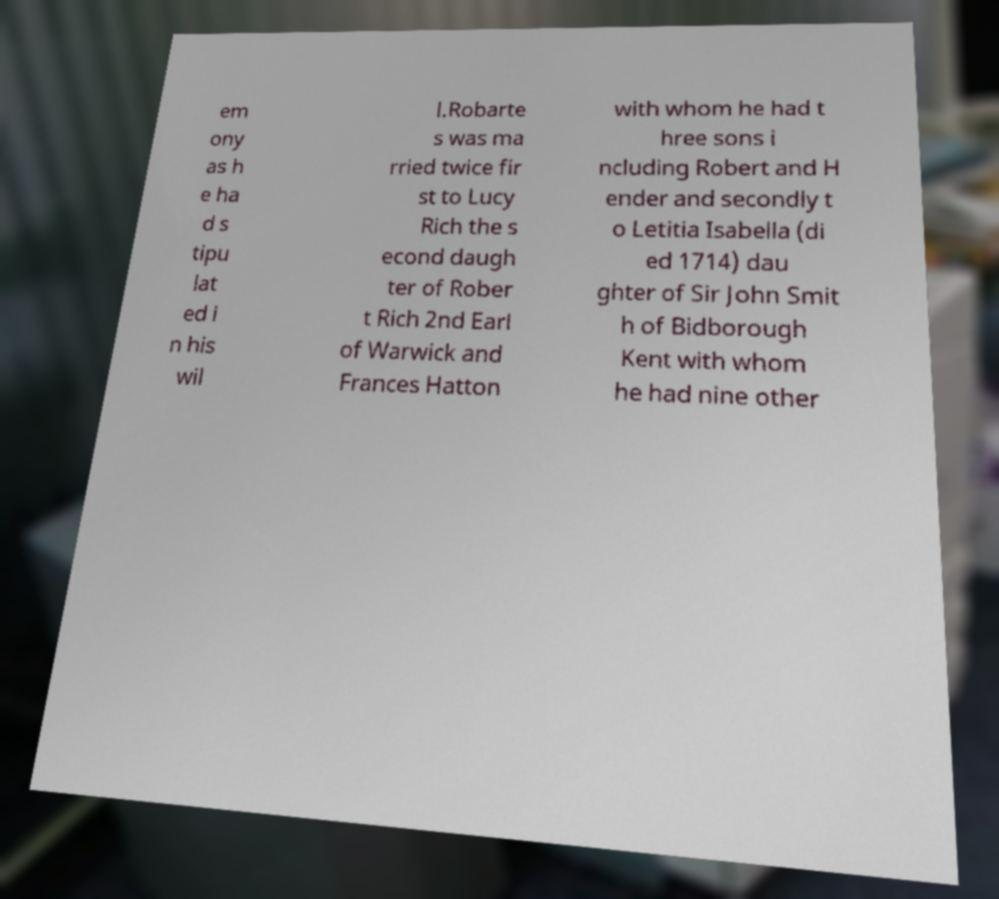Please identify and transcribe the text found in this image. em ony as h e ha d s tipu lat ed i n his wil l.Robarte s was ma rried twice fir st to Lucy Rich the s econd daugh ter of Rober t Rich 2nd Earl of Warwick and Frances Hatton with whom he had t hree sons i ncluding Robert and H ender and secondly t o Letitia Isabella (di ed 1714) dau ghter of Sir John Smit h of Bidborough Kent with whom he had nine other 